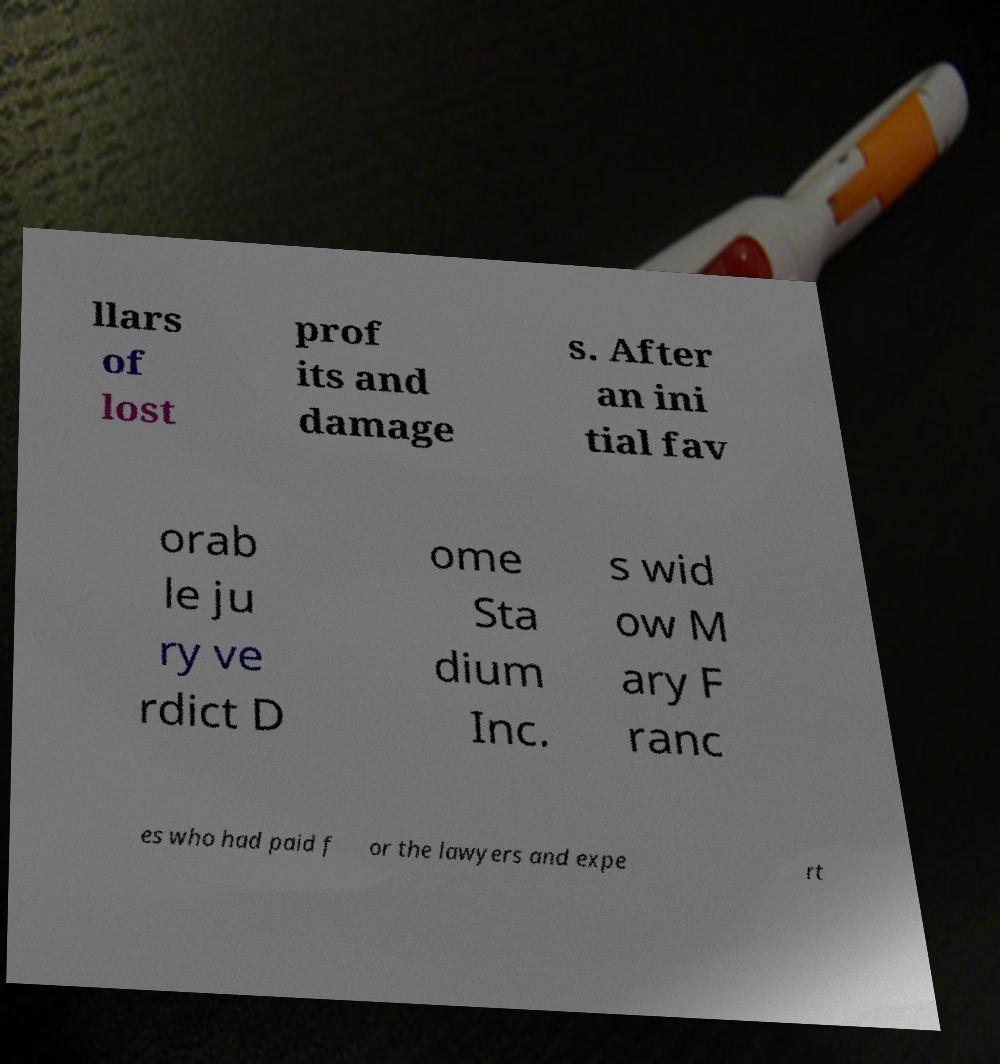For documentation purposes, I need the text within this image transcribed. Could you provide that? llars of lost prof its and damage s. After an ini tial fav orab le ju ry ve rdict D ome Sta dium Inc. s wid ow M ary F ranc es who had paid f or the lawyers and expe rt 